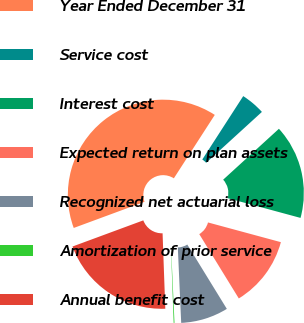Convert chart to OTSL. <chart><loc_0><loc_0><loc_500><loc_500><pie_chart><fcel>Year Ended December 31<fcel>Service cost<fcel>Interest cost<fcel>Expected return on plan assets<fcel>Recognized net actuarial loss<fcel>Amortization of prior service<fcel>Annual benefit cost<nl><fcel>39.75%<fcel>4.1%<fcel>15.98%<fcel>12.02%<fcel>8.06%<fcel>0.14%<fcel>19.94%<nl></chart> 